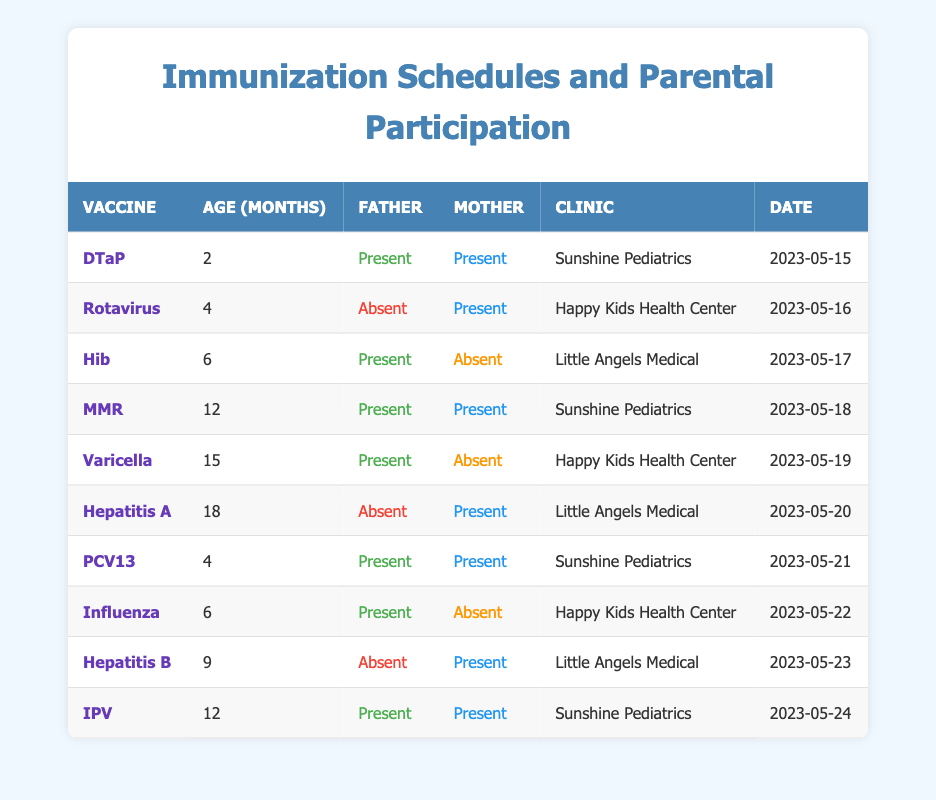What is the total number of vaccines administered when both parents were present? From the table, we examine each entry and count the vaccines where both the father and mother were present. Those entries are: DTaP (2 months), MMR (12 months), PCV13 (4 months), IPV (12 months). There are 4 entries.
Answer: 4 How many times did the father attend the vaccination appointments? By counting the rows where the father was present, we observe the father was present for DTaP, Hib, MMR, Varicella, PCV13, and Influenza. This gives us a total of 6 occurrences.
Answer: 6 Did both parents attend the Hepatitis A vaccination appointment? Looking at the entry for Hepatitis A, the table indicates that the father was absent while the mother was present. Therefore, both parents did not attend.
Answer: No What is the percentage of vaccines where the mother was present? There are 10 vaccines administered in total. The mother was present for DTaP, Rotavirus, MMR, Hepatitis A, PCV13, and IPV, which counts to 6 instances. The percentage is calculated as (6/10) * 100 = 60%.
Answer: 60% Which vaccine corresponds to the highest age at administration among those where only the father was present? Checking the entries, Varicella was administered at 15 months with the father present. This is the highest age for a vaccine where only the father was there, as Hib (present father, absent mother) was at 6 months.
Answer: Varicella How many vaccinations were conducted at Sunshine Pediatrics? There are three entries for Sunshine Pediatrics: DTaP, MMR, and IPV. This totals to 3 vaccinations at this clinic.
Answer: 3 Was there a vaccination appointment where only one parent was present? Yes, from the entries for Hib and Varicella vaccines, there were instances where one parent was present while the other was absent, specifically for Hib (father present, mother absent) and Hepatitis A (father absent, mother present).
Answer: Yes What is the total number of vaccinations administered for children aged 4 months? The table indicates two vaccinations at 4 months: Rotavirus (mother present, father absent) and PCV13 (both parents present). Therefore, the total is 2.
Answer: 2 In how many cases did the father attend when the mother did not? The father attended only one vaccination session, the Hib vaccine at 6 months, where the mother was not present.
Answer: 1 